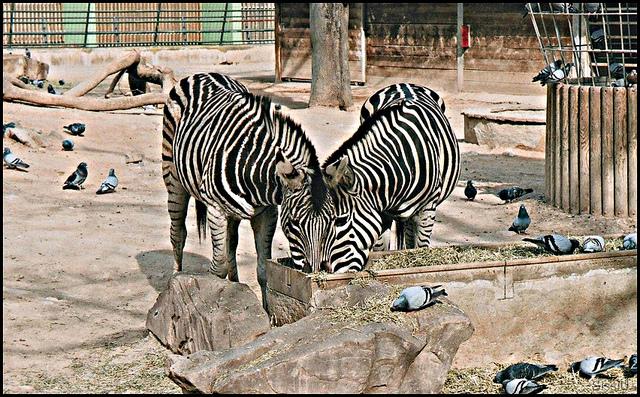What animal is there a lot of?
Write a very short answer. Birds. How many fence posts are there?
Write a very short answer. 2. How many zebra heads are in the picture?
Write a very short answer. 2. Is this shot indoors?
Concise answer only. No. 